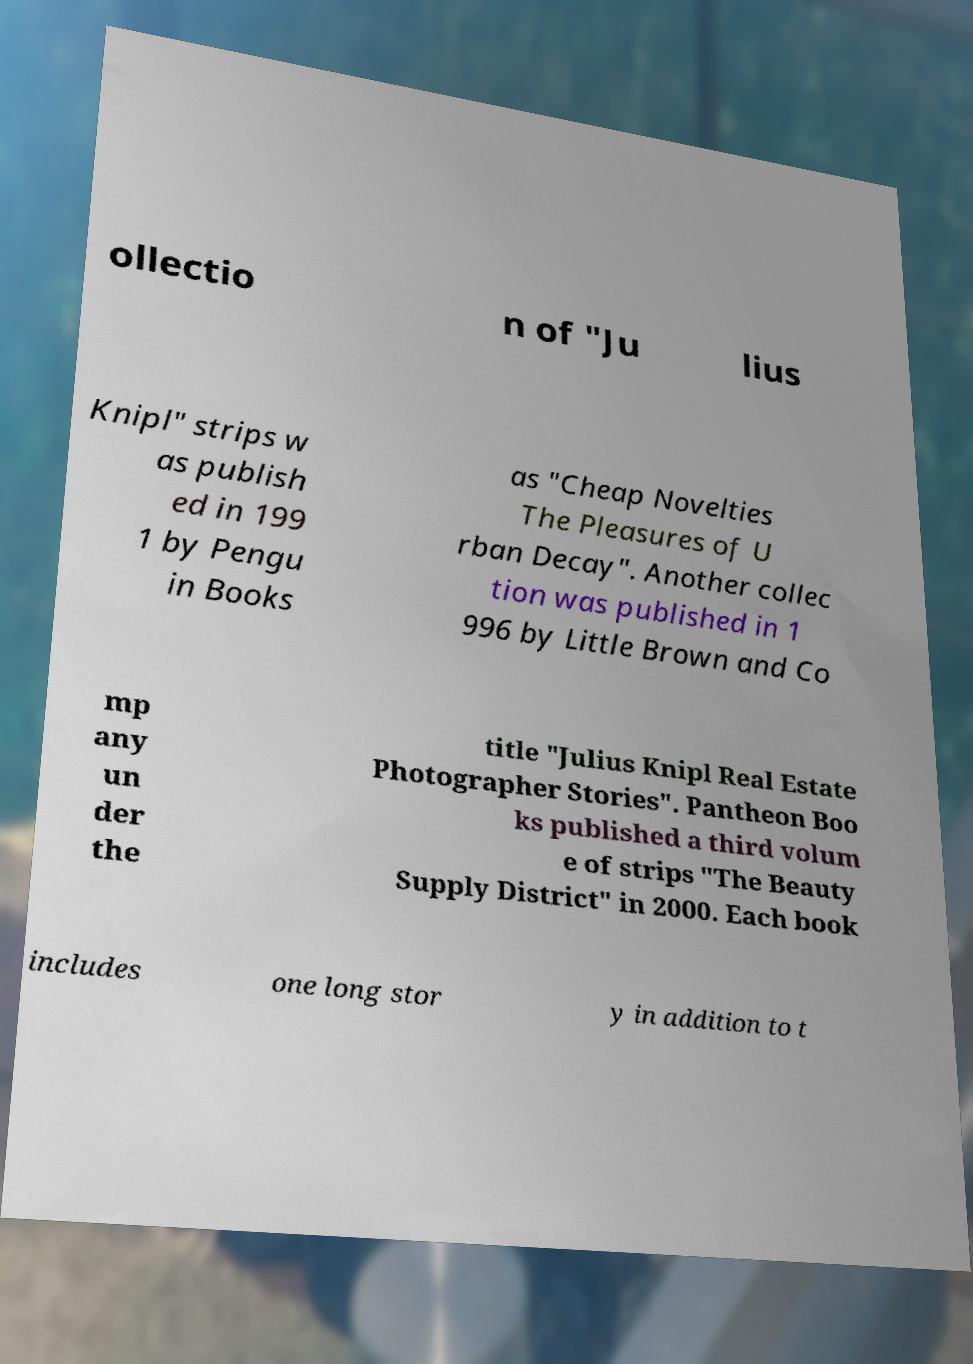Please identify and transcribe the text found in this image. ollectio n of "Ju lius Knipl" strips w as publish ed in 199 1 by Pengu in Books as "Cheap Novelties The Pleasures of U rban Decay". Another collec tion was published in 1 996 by Little Brown and Co mp any un der the title "Julius Knipl Real Estate Photographer Stories". Pantheon Boo ks published a third volum e of strips "The Beauty Supply District" in 2000. Each book includes one long stor y in addition to t 